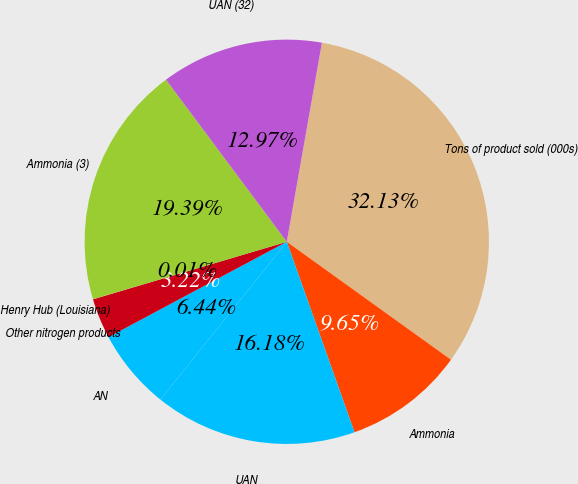Convert chart. <chart><loc_0><loc_0><loc_500><loc_500><pie_chart><fcel>Tons of product sold (000s)<fcel>Ammonia<fcel>UAN<fcel>AN<fcel>Other nitrogen products<fcel>Henry Hub (Louisiana)<fcel>Ammonia (3)<fcel>UAN (32)<nl><fcel>32.13%<fcel>9.65%<fcel>16.18%<fcel>6.44%<fcel>3.22%<fcel>0.01%<fcel>19.39%<fcel>12.97%<nl></chart> 